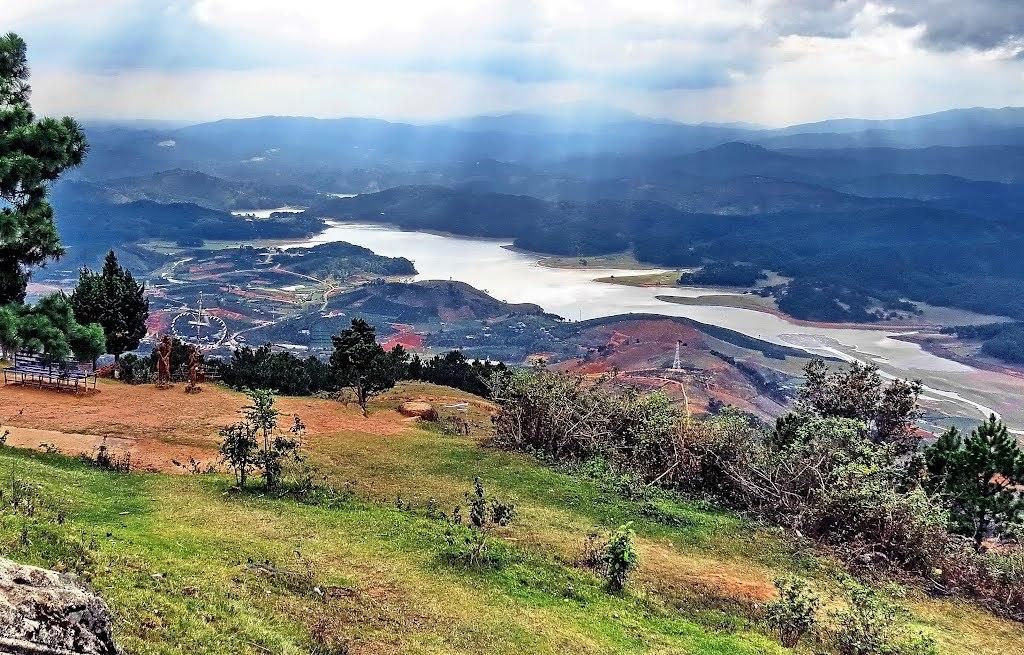What type of vegetation is present in the image? There are green color trees in the image. Where are the trees located in relation to the image? The trees are located at the down side of the image. What natural feature can be seen flowing in the image? There is a river flowing in the image. Where is the river situated in the image? The river is located in the middle of the image. What part of the natural environment is visible at the top of the image? The sky is visible at the top of the image. How would you describe the sky's appearance in the image? The sky is cloudy in the image. What caption can be seen on the trees in the image? There is no caption present on the trees in the image. Can you describe the stranger standing near the river in the image? There is no stranger present in the image; it only features trees, a river, and a cloudy sky. 